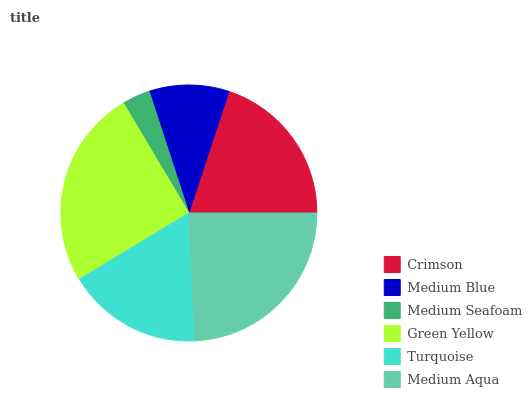Is Medium Seafoam the minimum?
Answer yes or no. Yes. Is Green Yellow the maximum?
Answer yes or no. Yes. Is Medium Blue the minimum?
Answer yes or no. No. Is Medium Blue the maximum?
Answer yes or no. No. Is Crimson greater than Medium Blue?
Answer yes or no. Yes. Is Medium Blue less than Crimson?
Answer yes or no. Yes. Is Medium Blue greater than Crimson?
Answer yes or no. No. Is Crimson less than Medium Blue?
Answer yes or no. No. Is Crimson the high median?
Answer yes or no. Yes. Is Turquoise the low median?
Answer yes or no. Yes. Is Medium Aqua the high median?
Answer yes or no. No. Is Crimson the low median?
Answer yes or no. No. 